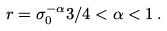<formula> <loc_0><loc_0><loc_500><loc_500>r = \sigma _ { 0 } ^ { - \alpha } 3 / 4 < \alpha < 1 \, .</formula> 